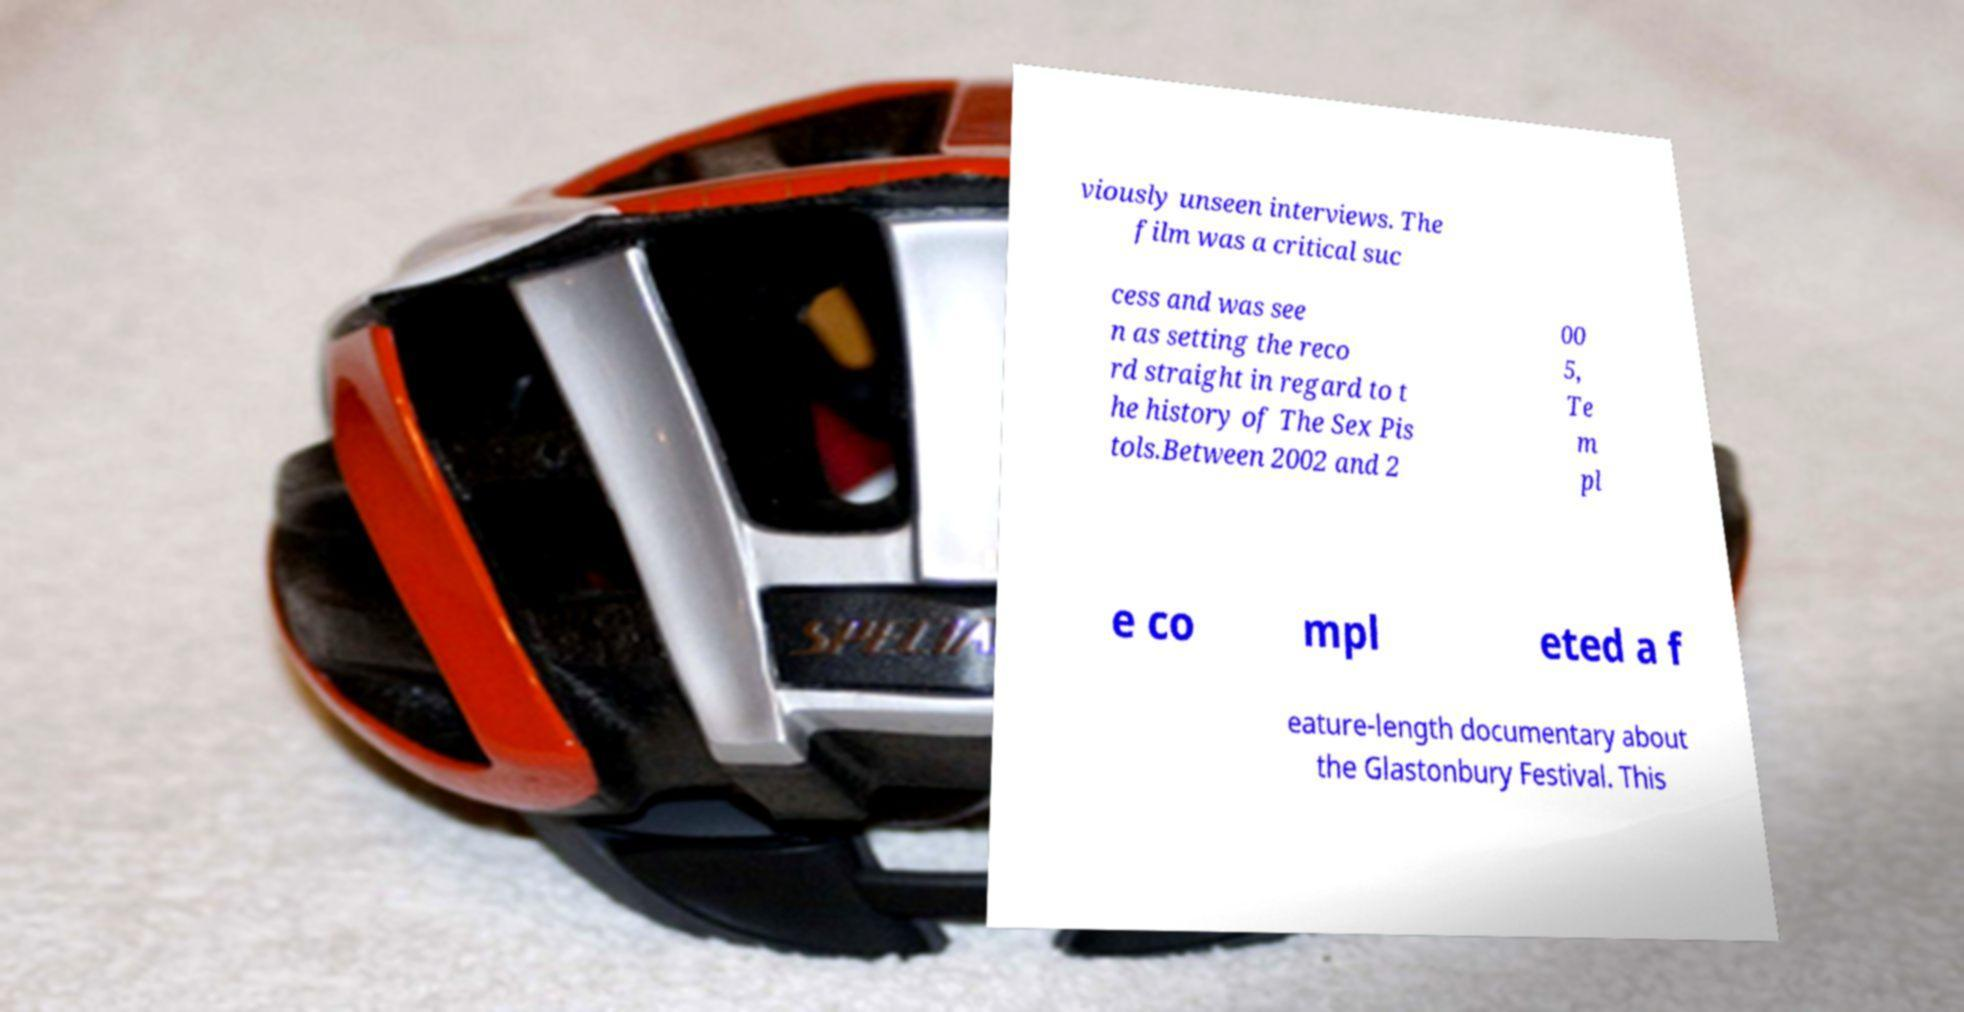Please identify and transcribe the text found in this image. viously unseen interviews. The film was a critical suc cess and was see n as setting the reco rd straight in regard to t he history of The Sex Pis tols.Between 2002 and 2 00 5, Te m pl e co mpl eted a f eature-length documentary about the Glastonbury Festival. This 